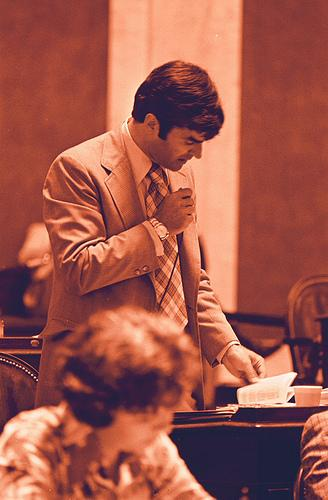Summarize the key aspects of the image in one sentence. A man in a suit, with a tie and a wristwatch, speaks into a microphone as he turns a page. Write an imaginary social media post describing the image. 🎤🕴️📖 Caught a candid shot of this stylish guy in a suit giving an amazing speech, turning pages while rocking his wristwatch! #PublicSpeakingGoals #SuitUp Present a short, informal description of the action depicted in the image. A dude in a suit, tie and with a watch on is giving a speech, and he's flipping a page. Create an image caption that highlights the main focus and some additional details. Eloquent speaker: a dapper man in a suit with a wristwatch and a tie, addressing a crowd and turning a page. Construct a brief narrative of the event taking place in the image. As the audience listens attentively, the poised man in a suit and tie delivers a compelling speech; his watch glimmers as he skillfully turns a page. Provide a concise description of the scene represented in the image. A man in a suit and tie with brown hair is standing up, speaking into a microphone, and turning a page with a watch around his wrist.  In a few sentences, describe the people and objects captured in the image. There's a standing man wearing a suit, tie, and a watch, who's speaking into a microphone. He has brown hair and is turning a page. A woman and a book on a desk are also visible. Tell a brief story about what you see happening in the image. In a formal setting, a well-groomed man in a suit confidently speaks into a microphone, captivating the audience's attention as he gracefully turns a page. Briefly mention the main focus of the picture along with any important details. The focus is on a man in a suit and tie with a watch on his wrist, who is addressing a microphone and flipping through pages. Using descriptive language, depict the primary subject and their actions in the image. A well-dressed man with brown hair, donning a suit and tie, gracefully extends his hand to turn a page as he articulates his thoughts into a nearby microphone. 